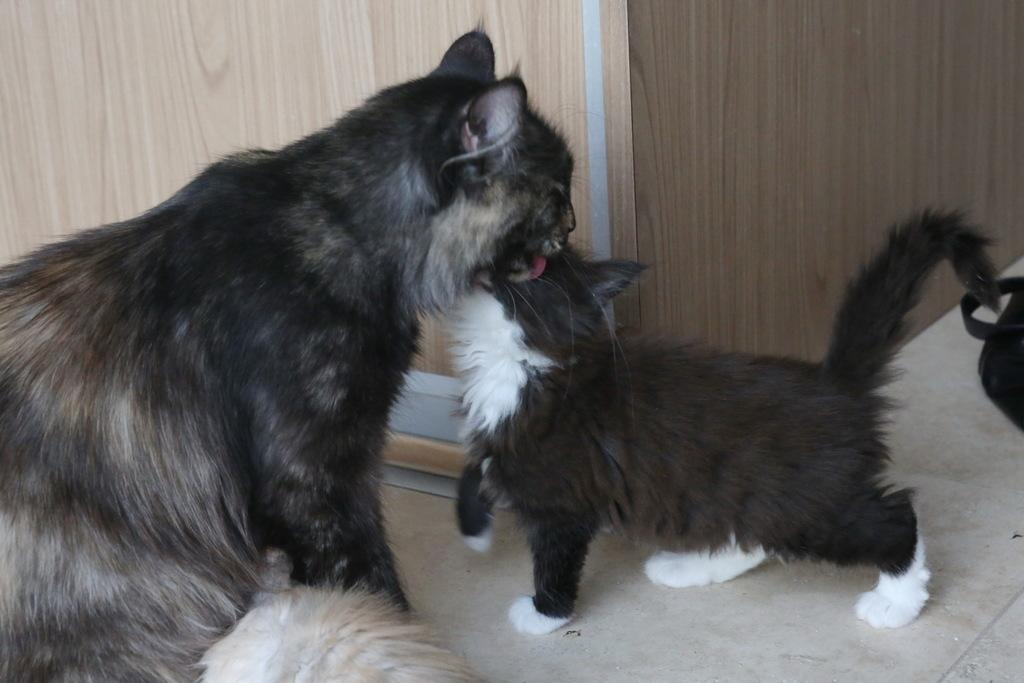How many cats are present in the image? There are two cats in the image. What is the background or setting behind the cats? The cats are in front of a wooden wall. What decision did the cats make in the image? There is no indication of a decision made by the cats in the image. 